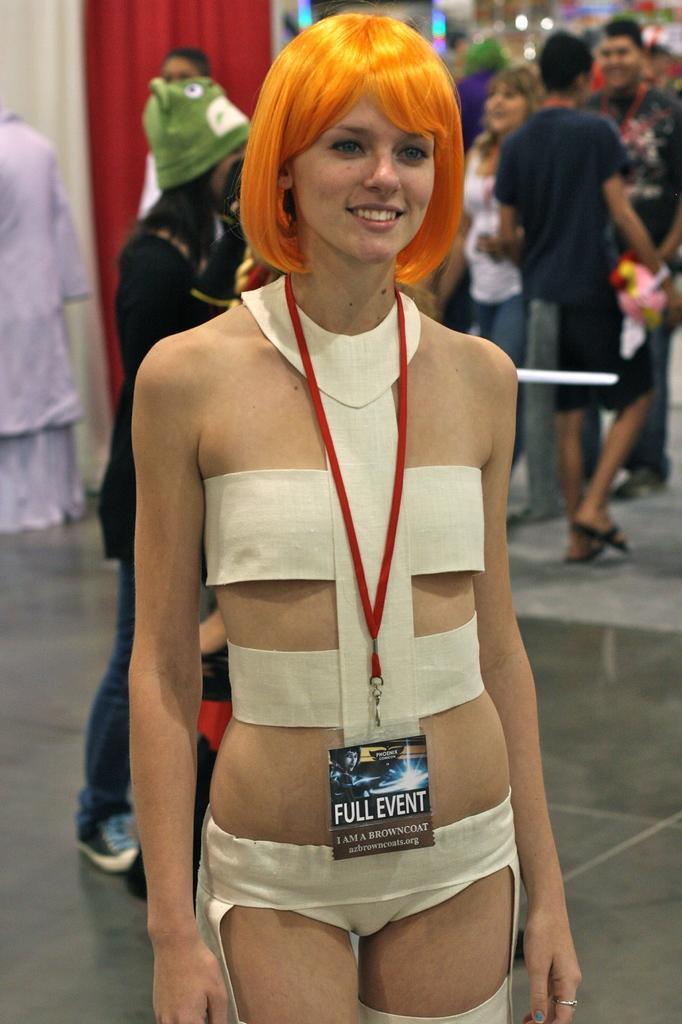In one or two sentences, can you explain what this image depicts? In this picture I can see there is a woman standing, she is wearing a ID card and a white dress, she is smiling and there are few people standing and there is a red color curtain in the backdrop. 